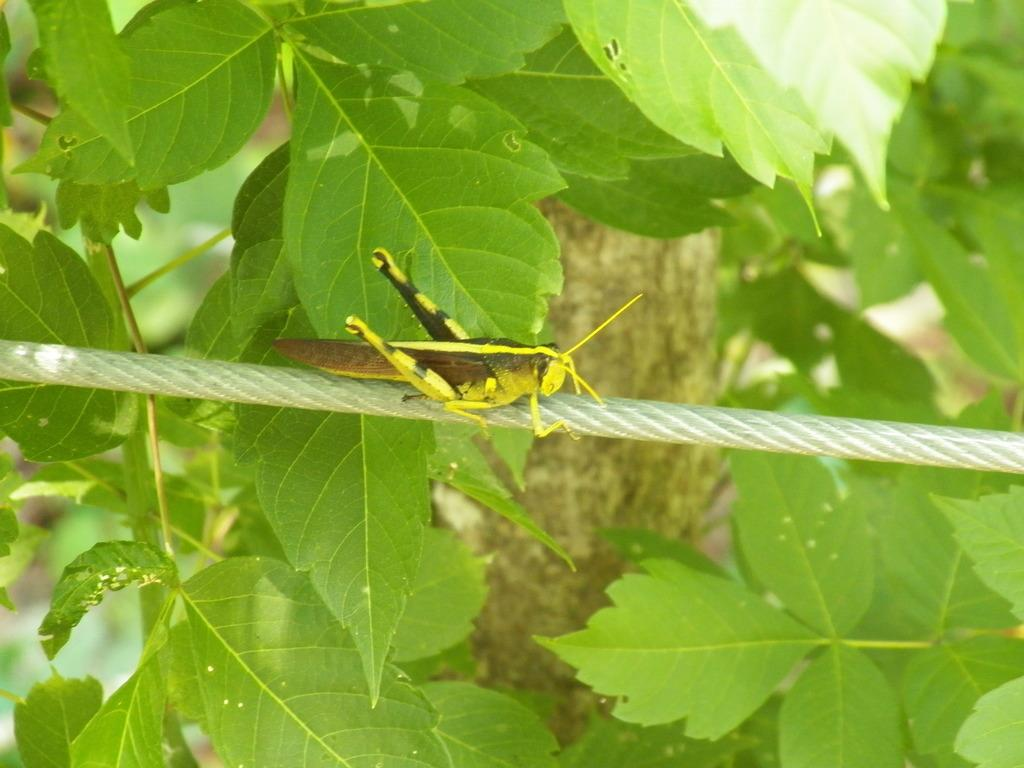What is the main subject of the image? There is a grasshopper in the image. What is the grasshopper doing or resting on? The grasshopper is on a thread. What can be seen in the background of the image? There are leaves visible in the background of the image. What type of shoes is the grasshopper wearing in the image? There are no shoes present in the image, as grasshoppers do not wear shoes. 